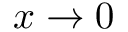<formula> <loc_0><loc_0><loc_500><loc_500>x \to 0</formula> 